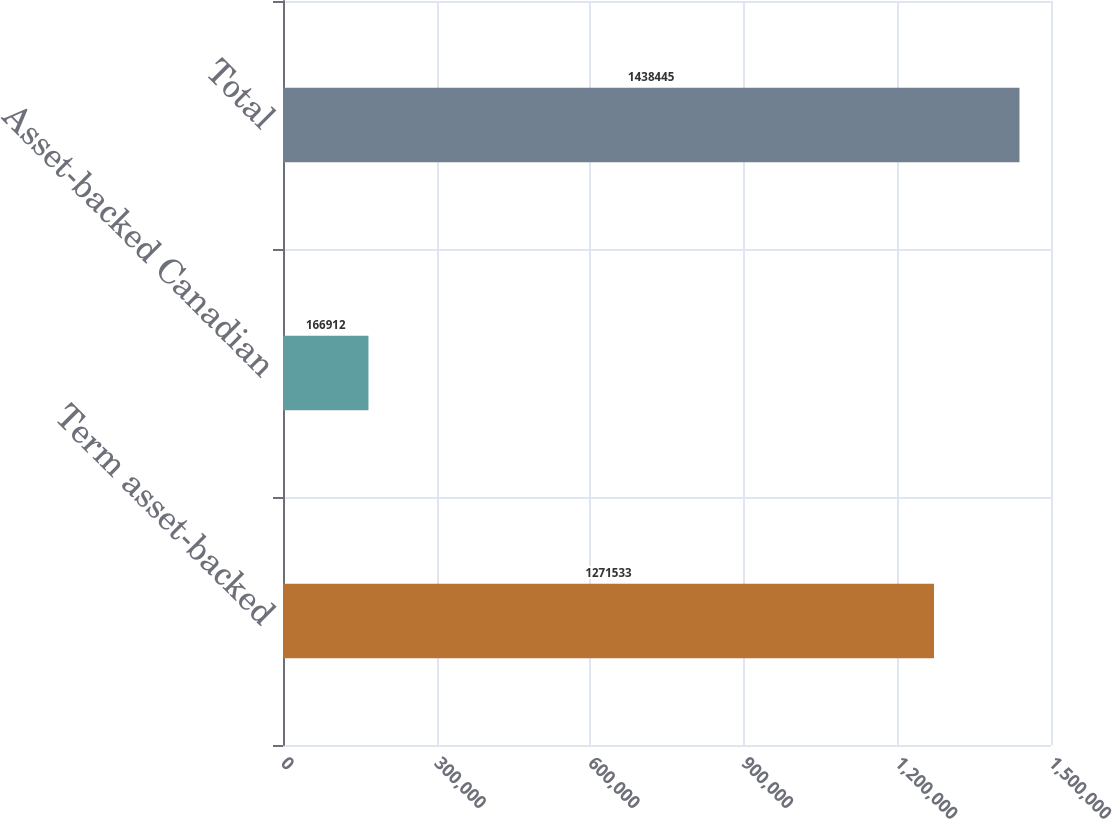<chart> <loc_0><loc_0><loc_500><loc_500><bar_chart><fcel>Term asset-backed<fcel>Asset-backed Canadian<fcel>Total<nl><fcel>1.27153e+06<fcel>166912<fcel>1.43844e+06<nl></chart> 